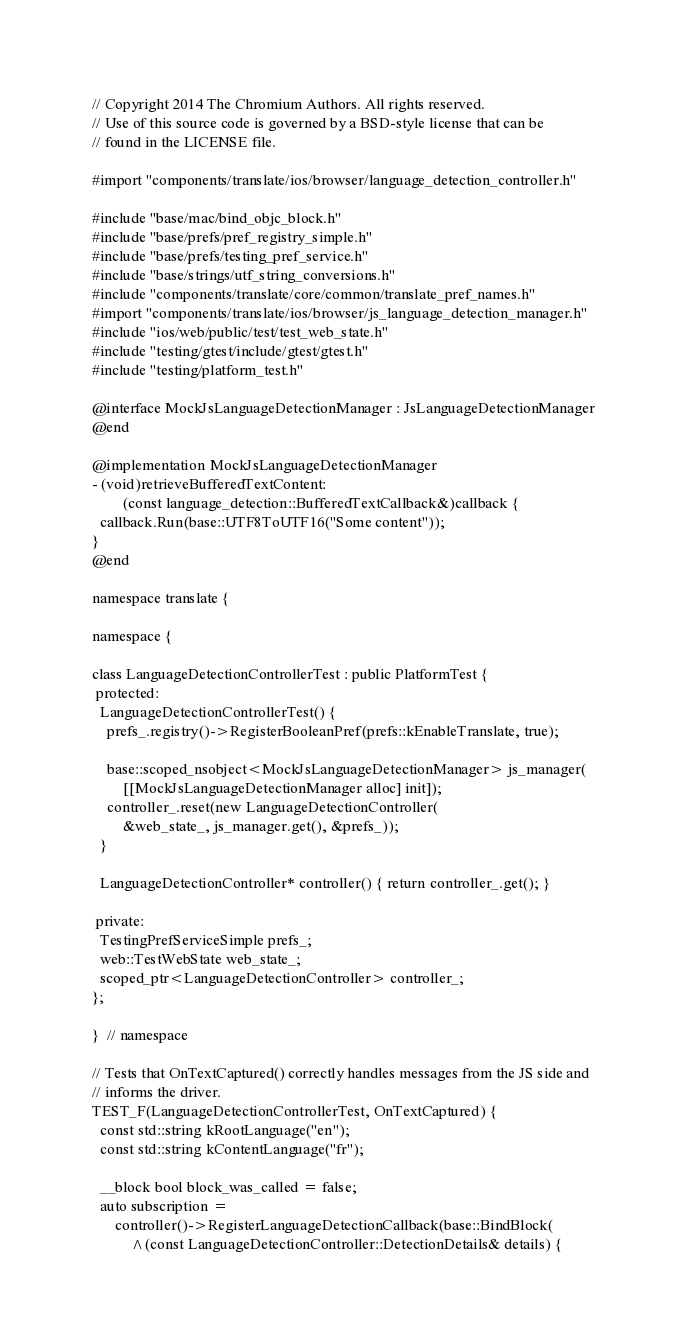<code> <loc_0><loc_0><loc_500><loc_500><_ObjectiveC_>// Copyright 2014 The Chromium Authors. All rights reserved.
// Use of this source code is governed by a BSD-style license that can be
// found in the LICENSE file.

#import "components/translate/ios/browser/language_detection_controller.h"

#include "base/mac/bind_objc_block.h"
#include "base/prefs/pref_registry_simple.h"
#include "base/prefs/testing_pref_service.h"
#include "base/strings/utf_string_conversions.h"
#include "components/translate/core/common/translate_pref_names.h"
#import "components/translate/ios/browser/js_language_detection_manager.h"
#include "ios/web/public/test/test_web_state.h"
#include "testing/gtest/include/gtest/gtest.h"
#include "testing/platform_test.h"

@interface MockJsLanguageDetectionManager : JsLanguageDetectionManager
@end

@implementation MockJsLanguageDetectionManager
- (void)retrieveBufferedTextContent:
        (const language_detection::BufferedTextCallback&)callback {
  callback.Run(base::UTF8ToUTF16("Some content"));
}
@end

namespace translate {

namespace {

class LanguageDetectionControllerTest : public PlatformTest {
 protected:
  LanguageDetectionControllerTest() {
    prefs_.registry()->RegisterBooleanPref(prefs::kEnableTranslate, true);

    base::scoped_nsobject<MockJsLanguageDetectionManager> js_manager(
        [[MockJsLanguageDetectionManager alloc] init]);
    controller_.reset(new LanguageDetectionController(
        &web_state_, js_manager.get(), &prefs_));
  }

  LanguageDetectionController* controller() { return controller_.get(); }

 private:
  TestingPrefServiceSimple prefs_;
  web::TestWebState web_state_;
  scoped_ptr<LanguageDetectionController> controller_;
};

}  // namespace

// Tests that OnTextCaptured() correctly handles messages from the JS side and
// informs the driver.
TEST_F(LanguageDetectionControllerTest, OnTextCaptured) {
  const std::string kRootLanguage("en");
  const std::string kContentLanguage("fr");

  __block bool block_was_called = false;
  auto subscription =
      controller()->RegisterLanguageDetectionCallback(base::BindBlock(
          ^(const LanguageDetectionController::DetectionDetails& details) {</code> 